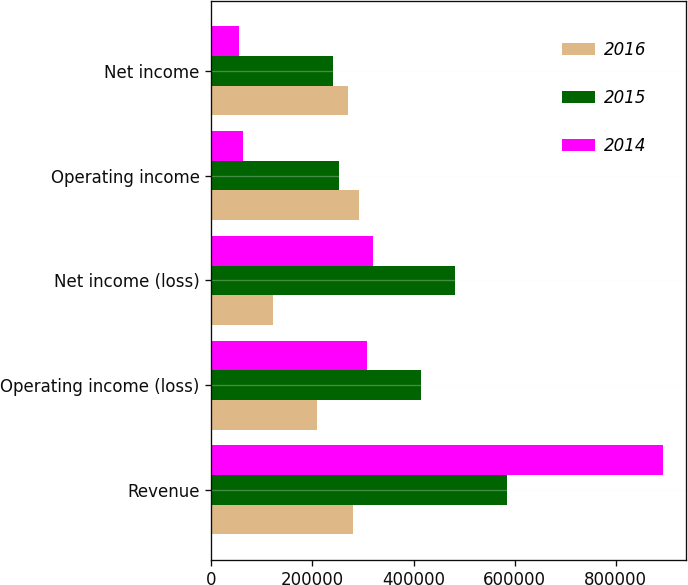Convert chart to OTSL. <chart><loc_0><loc_0><loc_500><loc_500><stacked_bar_chart><ecel><fcel>Revenue<fcel>Operating income (loss)<fcel>Net income (loss)<fcel>Operating income<fcel>Net income<nl><fcel>2016<fcel>280991<fcel>209230<fcel>122560<fcel>292141<fcel>269841<nl><fcel>2015<fcel>585495<fcel>414538<fcel>481405<fcel>251557<fcel>240034<nl><fcel>2014<fcel>894725<fcel>307133<fcel>320206<fcel>63181<fcel>54468<nl></chart> 